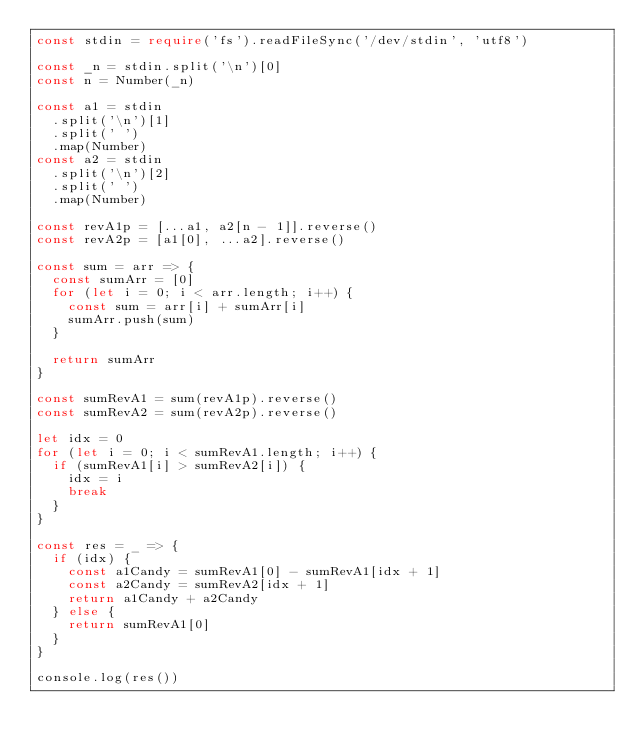Convert code to text. <code><loc_0><loc_0><loc_500><loc_500><_TypeScript_>const stdin = require('fs').readFileSync('/dev/stdin', 'utf8')

const _n = stdin.split('\n')[0]
const n = Number(_n)

const a1 = stdin
  .split('\n')[1]
  .split(' ')
  .map(Number)
const a2 = stdin
  .split('\n')[2]
  .split(' ')
  .map(Number)

const revA1p = [...a1, a2[n - 1]].reverse()
const revA2p = [a1[0], ...a2].reverse()

const sum = arr => {
  const sumArr = [0]
  for (let i = 0; i < arr.length; i++) {
    const sum = arr[i] + sumArr[i]
    sumArr.push(sum)
  }

  return sumArr
}

const sumRevA1 = sum(revA1p).reverse()
const sumRevA2 = sum(revA2p).reverse()

let idx = 0
for (let i = 0; i < sumRevA1.length; i++) {
  if (sumRevA1[i] > sumRevA2[i]) {
    idx = i
    break
  }
}

const res = _ => {
  if (idx) {
    const a1Candy = sumRevA1[0] - sumRevA1[idx + 1]
    const a2Candy = sumRevA2[idx + 1]
    return a1Candy + a2Candy
  } else {
    return sumRevA1[0]
  }
}

console.log(res())
</code> 